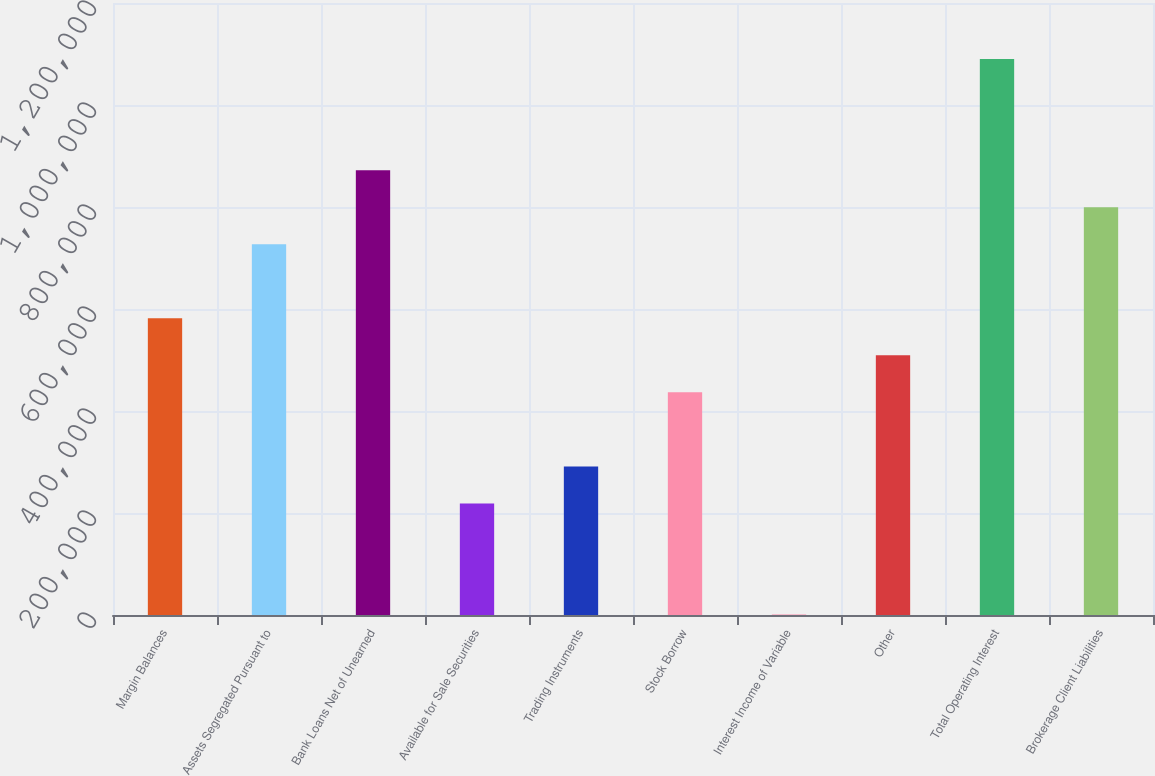<chart> <loc_0><loc_0><loc_500><loc_500><bar_chart><fcel>Margin Balances<fcel>Assets Segregated Pursuant to<fcel>Bank Loans Net of Unearned<fcel>Available for Sale Securities<fcel>Trading Instruments<fcel>Stock Borrow<fcel>Interest Income of Variable<fcel>Other<fcel>Total Operating Interest<fcel>Brokerage Client Liabilities<nl><fcel>581785<fcel>726992<fcel>872199<fcel>218766<fcel>291370<fcel>436577<fcel>955<fcel>509181<fcel>1.09001e+06<fcel>799596<nl></chart> 